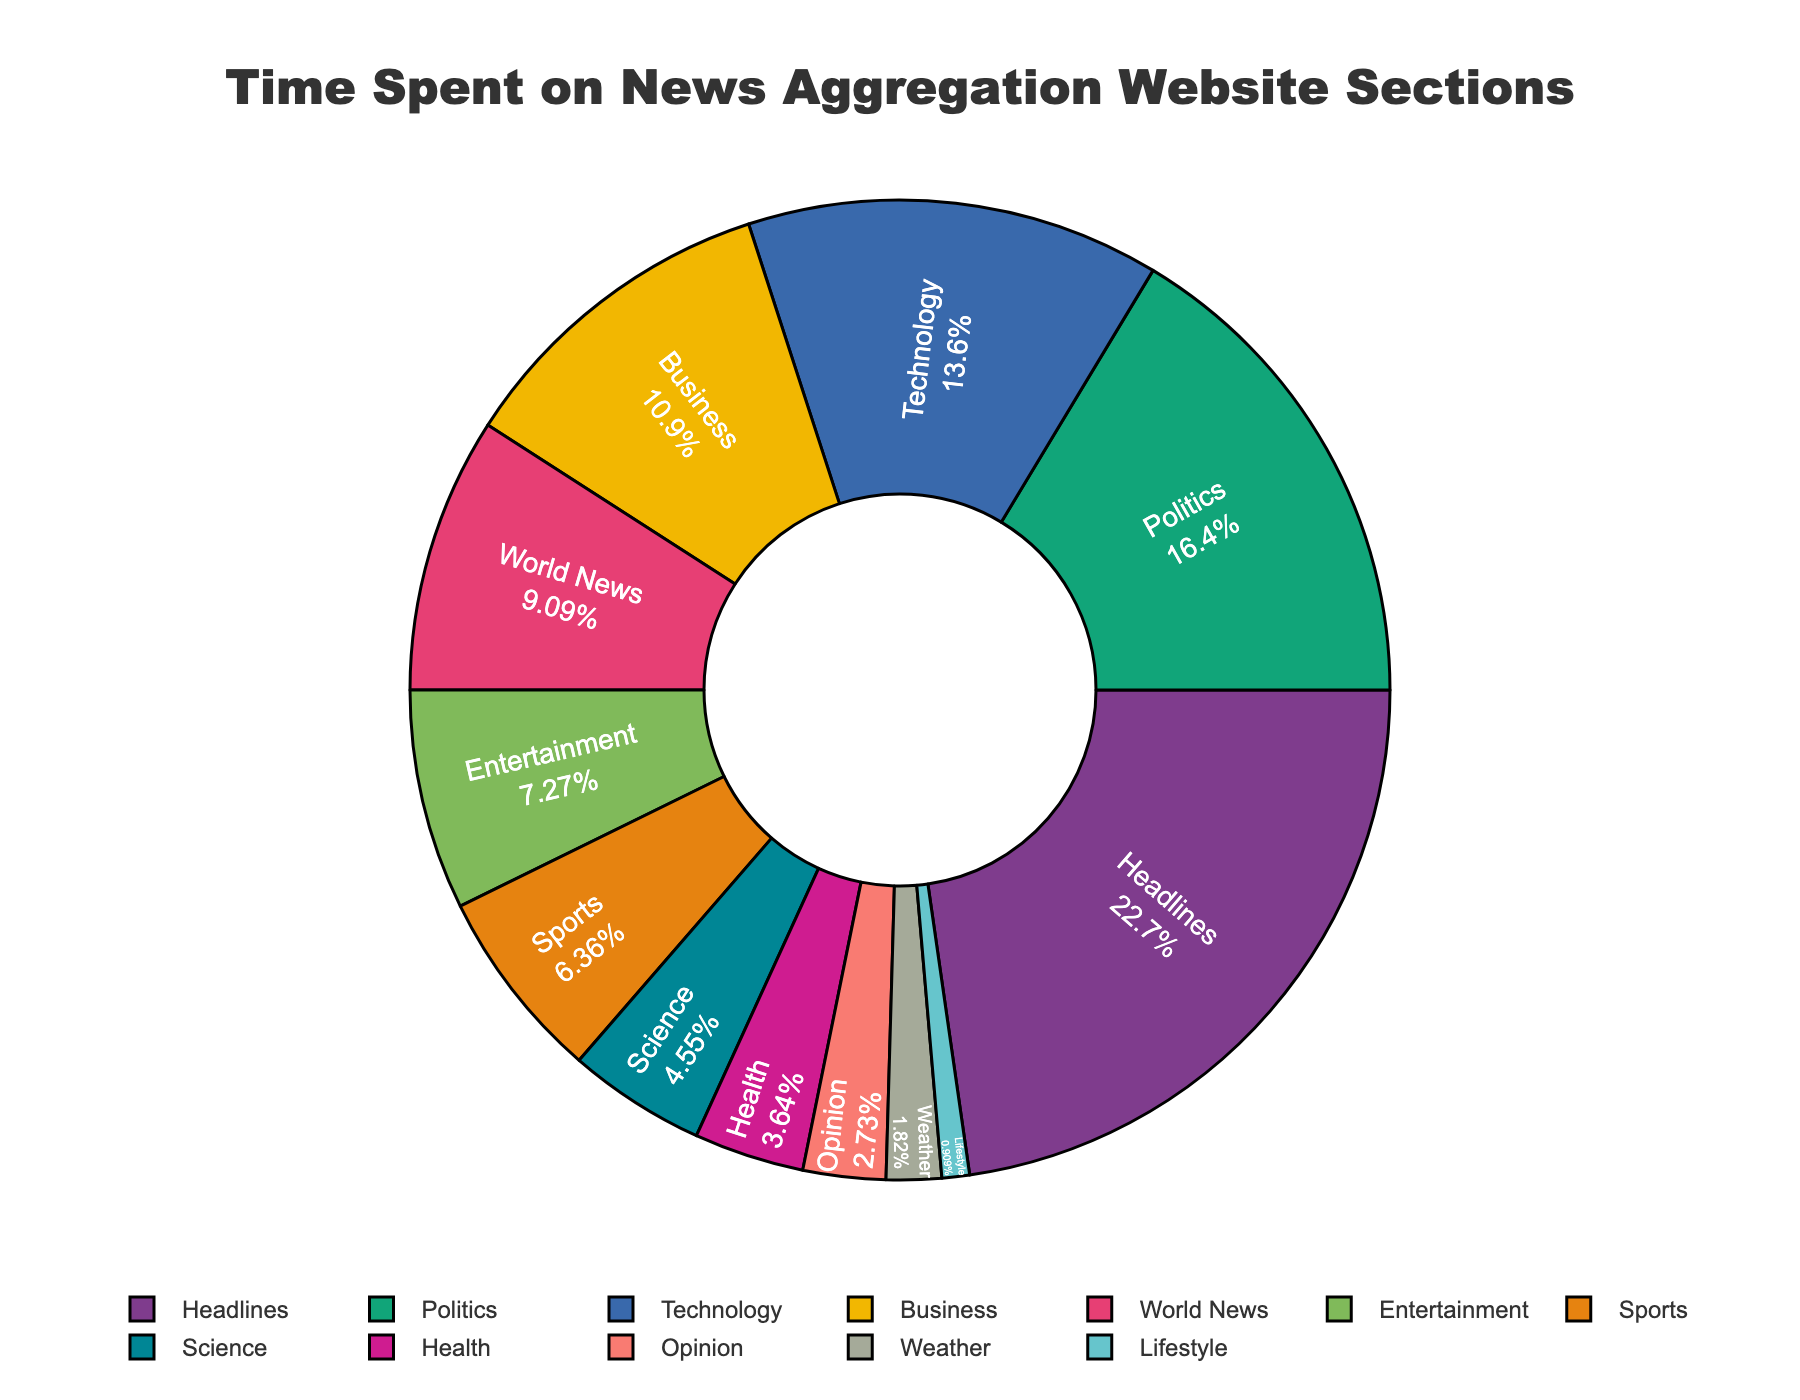What's the total percentage of time spent on 'Headlines', 'Politics', and 'Technology' sections? First, locate the percentage values for 'Headlines' (25%), 'Politics' (18%), and 'Technology' (15%) in the figure. Then, sum them up: 25% + 18% + 15% = 58%.
Answer: 58% Which section has more time spent: 'Business' or 'World News'? Identify the time percentages for 'Business' (12%) and 'World News' (10%). Compare the two values: 12% is greater than 10%.
Answer: Business What is the second most visited section on the website? Observe the chart to find the section with the second highest percentage. The highest is 'Headlines' (25%), followed by 'Politics' (18%). Therefore, 'Politics' is the second most visited section.
Answer: Politics How does the time spent on 'Sports' compare to 'Entertainment'? Check the time percentages for 'Sports' (7%) and 'Entertainment' (8%). Since 8% (Entertainment) is greater than 7% (Sports), 'Entertainment' has more time spent.
Answer: Entertainment If users spent 20 hours on the 'Health' section, how much time did they likely spend on the 'Headlines' section? We need to convert the relative percentages to actual hours. 'Health' time spent is 4%, which equates to 20 hours. Since 'Headlines' time spent is 25%, we apply the ratio: 20 hours / 4% * 25% = 125 hours.
Answer: 125 hours What's the difference in time spent between 'Sports' and 'Science' sections? Find the time spent percentages: 'Sports' is 7% and 'Science' is 5%. Calculate the difference: 7% - 5% = 2%.
Answer: 2% What percentage of time is spent on sections related to 'Technology' and 'Science' combined? Locate the percentages for 'Technology' (15%) and 'Science' (5%). Sum them: 15% + 5% = 20%.
Answer: 20% Which section has the least time spent, and what is that percentage? Identify the section with the smallest segment. 'Lifestyle' has the least time spent with 1%.
Answer: Lifestyle, 1% How does the time spent on 'Opinion' compare to that on 'Weather'? Observe that 'Opinion' has 3% and 'Weather' has 2%. Compare the two: 3% is greater than 2%.
Answer: Opinion 